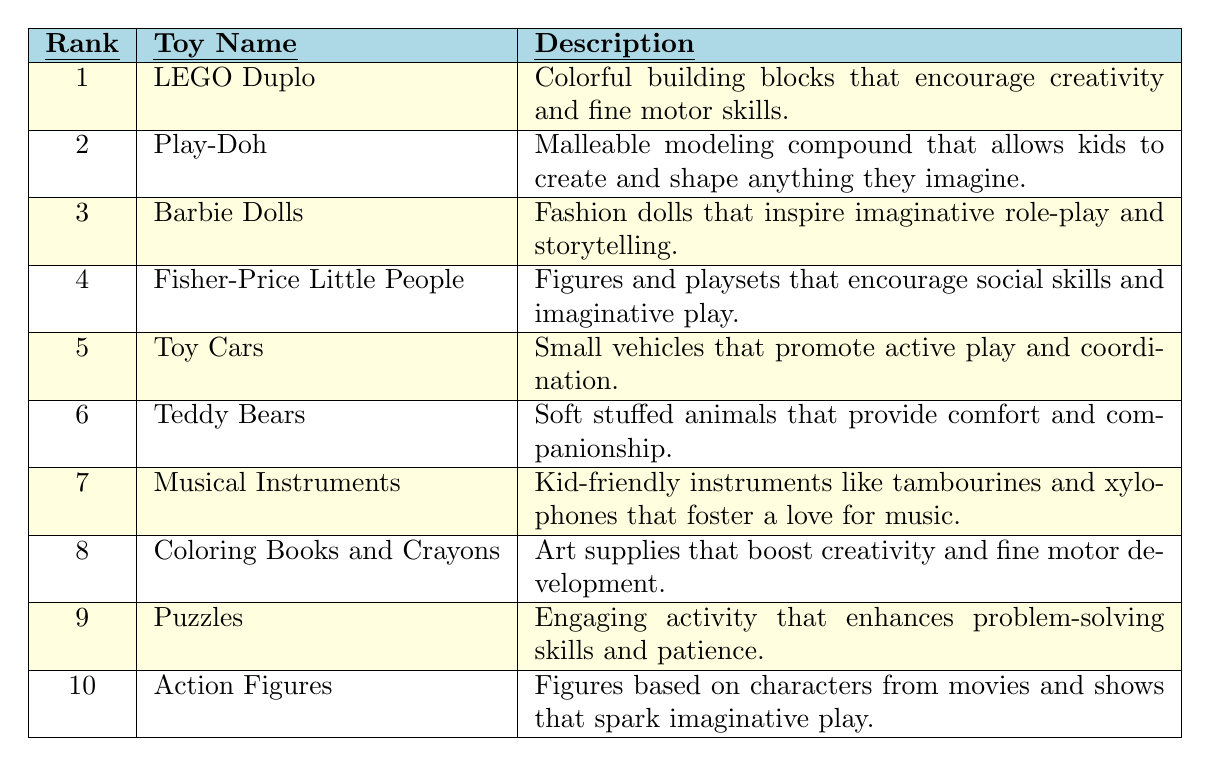What is the most popular toy according to the table? The table lists the popularity ranks for the toys, and the toy with the highest rank (1) is LEGO Duplo.
Answer: LEGO Duplo How many toys are ranked in the table? The table has a total of 10 toys listed with their ranks.
Answer: 10 Which toy is ranked fifth? The table indicates that Toy Cars are ranked fifth, as per the popularity rank column.
Answer: Toy Cars Do any toys encourage creativity? Yes, the table lists at least two toys (LEGO Duplo and Coloring Books and Crayons) that explicitly mention encouraging creativity in their descriptions.
Answer: Yes Which toy has a description mentioning social skills? The Fisher-Price Little People toy is described as encouraging social skills and imaginative play.
Answer: Fisher-Price Little People What is the difference in popularity rank between Play-Doh and Action Figures? The popularity rank for Play-Doh is 2 and for Action Figures is 10. Therefore, the difference is 10 - 2 = 8.
Answer: 8 Is the description of Teddy Bears related to comfort? Yes, the description of Teddy Bears states that they provide comfort and companionship.
Answer: Yes Which toy ranked immediately below Barbie Dolls? Barbie Dolls are ranked third, so the toy ranked immediately below is Fisher-Price Little People, ranked fourth.
Answer: Fisher-Price Little People What toy description mentions fine motor skills? LEGO Duplo’s description states that it encourages creativity and fine motor skills.
Answer: LEGO Duplo Which toy has a higher rank, Musical Instruments or Puzzles? Musical Instruments is ranked 7th while Puzzles is ranked 9th, so Musical Instruments has a higher rank.
Answer: Musical Instruments Does the table show any toy that fosters a love for music? Yes, the description of Musical Instruments mentions that it fosters a love for music.
Answer: Yes What is the sum of the ranks for Toy Cars and Teddy Bears? Toy Cars are ranked 5th and Teddy Bears are ranked 6th. The sum is 5 + 6 = 11.
Answer: 11 Is there any toy in the table that is related to role-play? Yes, Barbie Dolls inspire imaginative role-play according to their description.
Answer: Yes Which toys are specifically designed to enhance problem-solving skills? Puzzles are explicitly mentioned in the table as enhancing problem-solving skills.
Answer: Puzzles What is the average rank of the first three toys? The ranks for the first three toys are 1 (LEGO Duplo), 2 (Play-Doh), and 3 (Barbie Dolls). The average is (1 + 2 + 3) / 3 = 2.
Answer: 2 